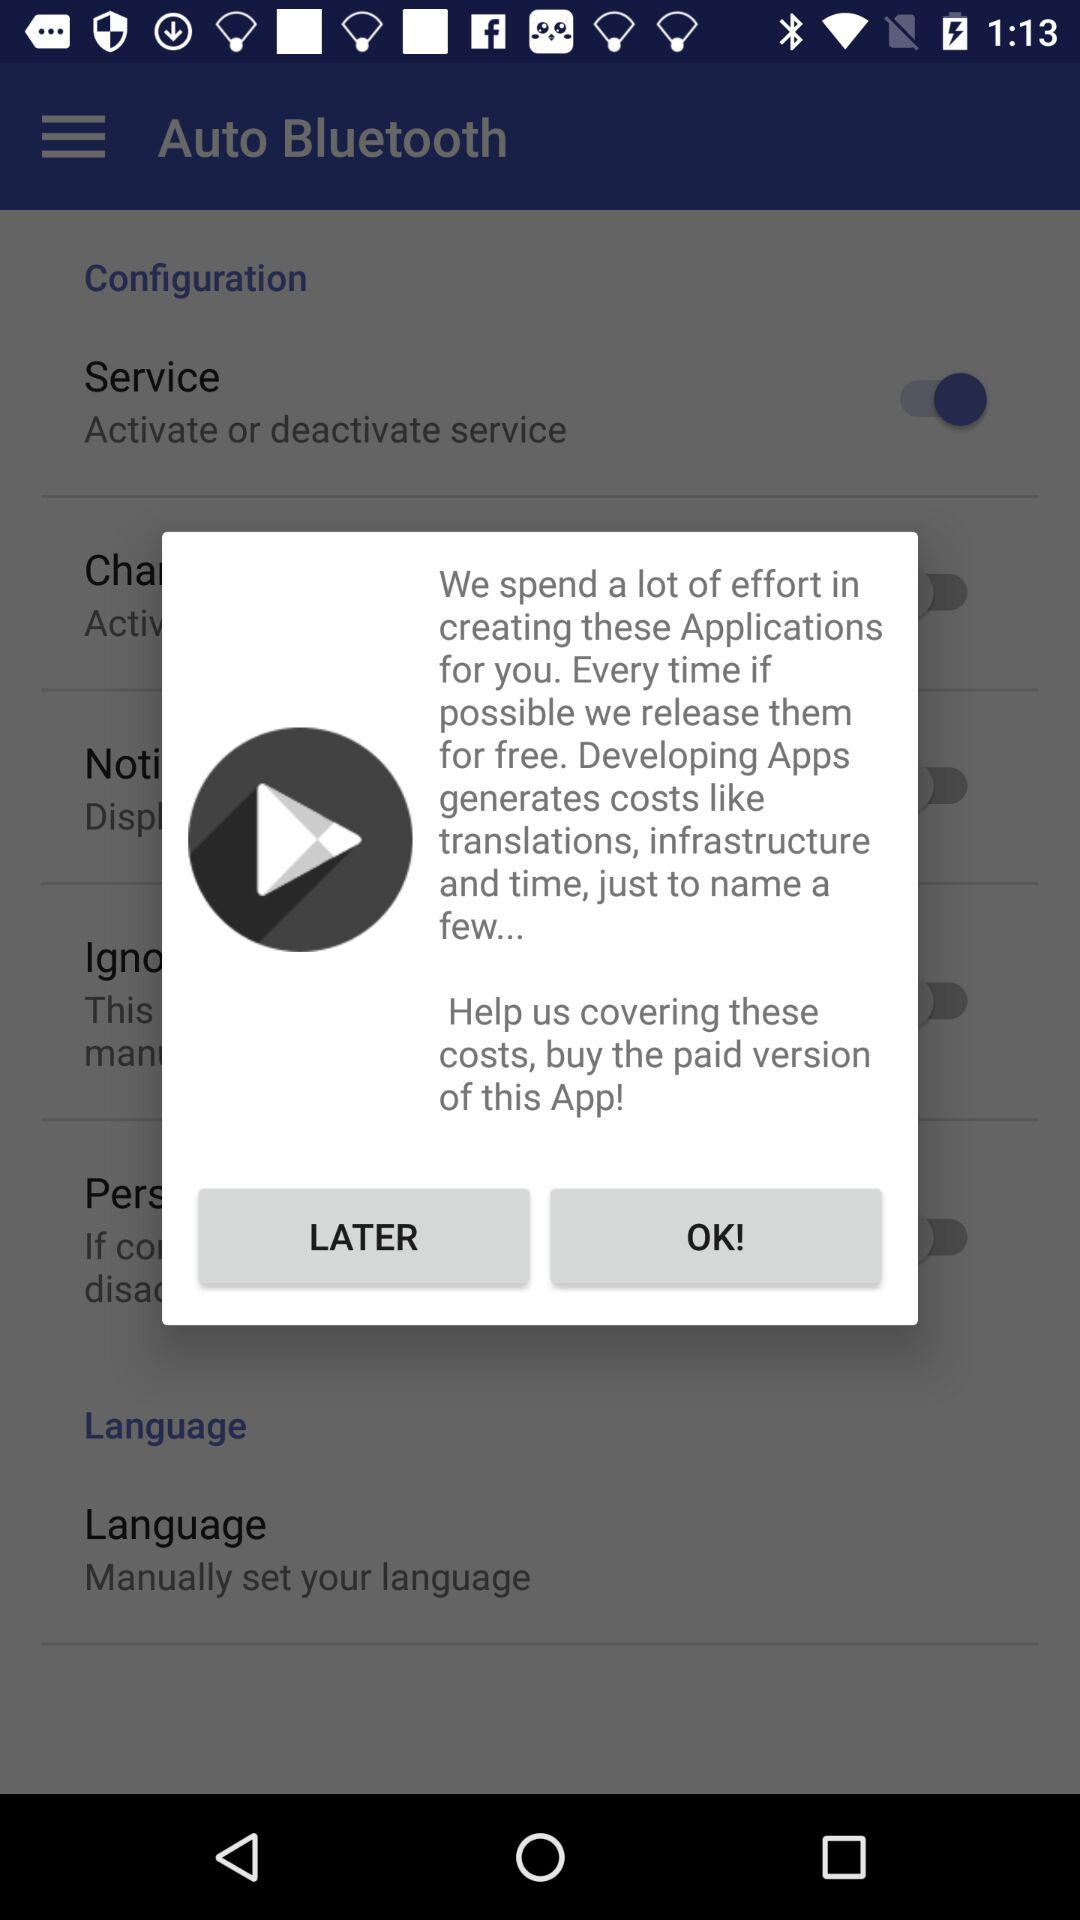What is the status of "Service"? The status is "on". 